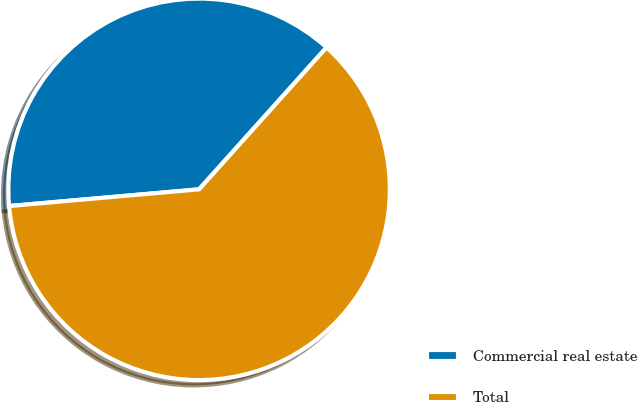Convert chart. <chart><loc_0><loc_0><loc_500><loc_500><pie_chart><fcel>Commercial real estate<fcel>Total<nl><fcel>38.04%<fcel>61.96%<nl></chart> 